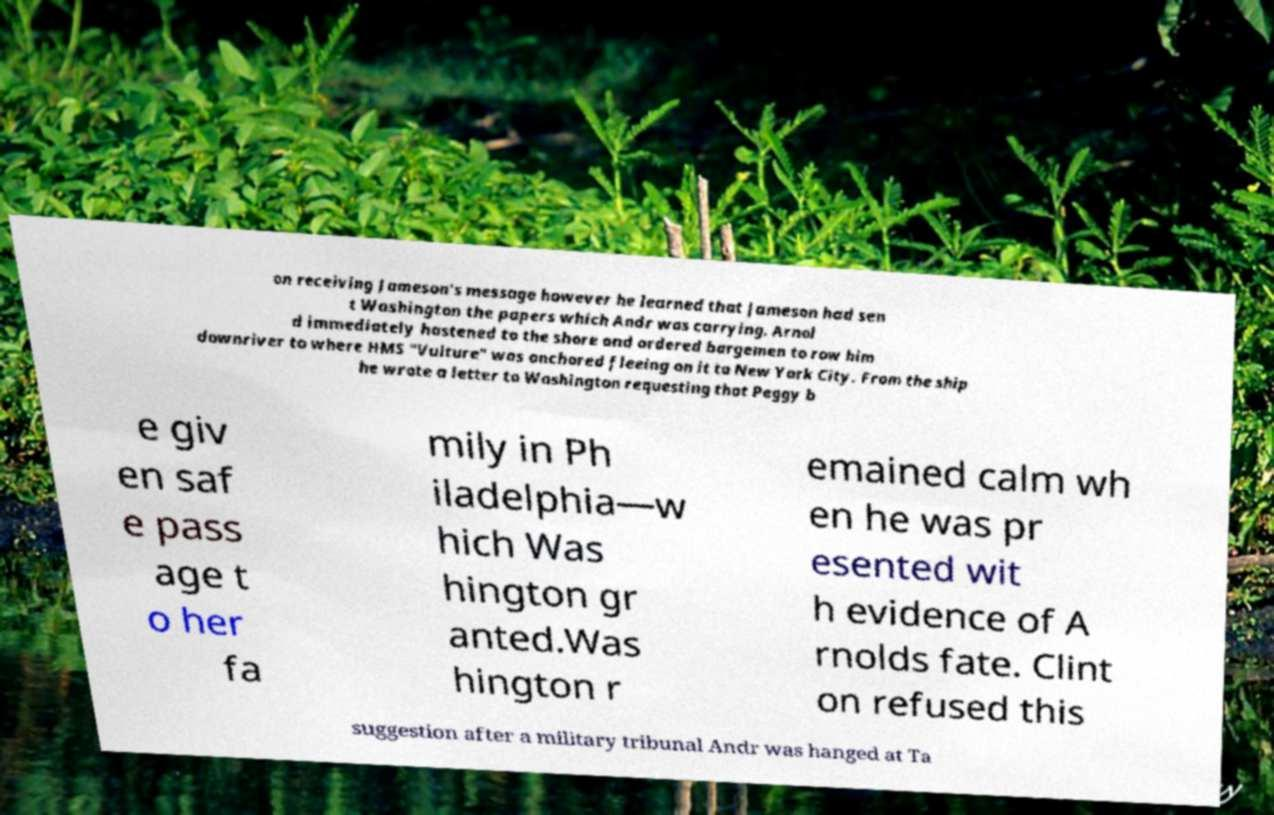Can you read and provide the text displayed in the image?This photo seems to have some interesting text. Can you extract and type it out for me? on receiving Jameson's message however he learned that Jameson had sen t Washington the papers which Andr was carrying. Arnol d immediately hastened to the shore and ordered bargemen to row him downriver to where HMS "Vulture" was anchored fleeing on it to New York City. From the ship he wrote a letter to Washington requesting that Peggy b e giv en saf e pass age t o her fa mily in Ph iladelphia—w hich Was hington gr anted.Was hington r emained calm wh en he was pr esented wit h evidence of A rnolds fate. Clint on refused this suggestion after a military tribunal Andr was hanged at Ta 